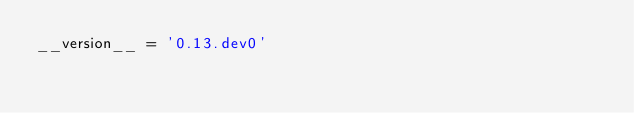Convert code to text. <code><loc_0><loc_0><loc_500><loc_500><_Python_>__version__ = '0.13.dev0'
</code> 